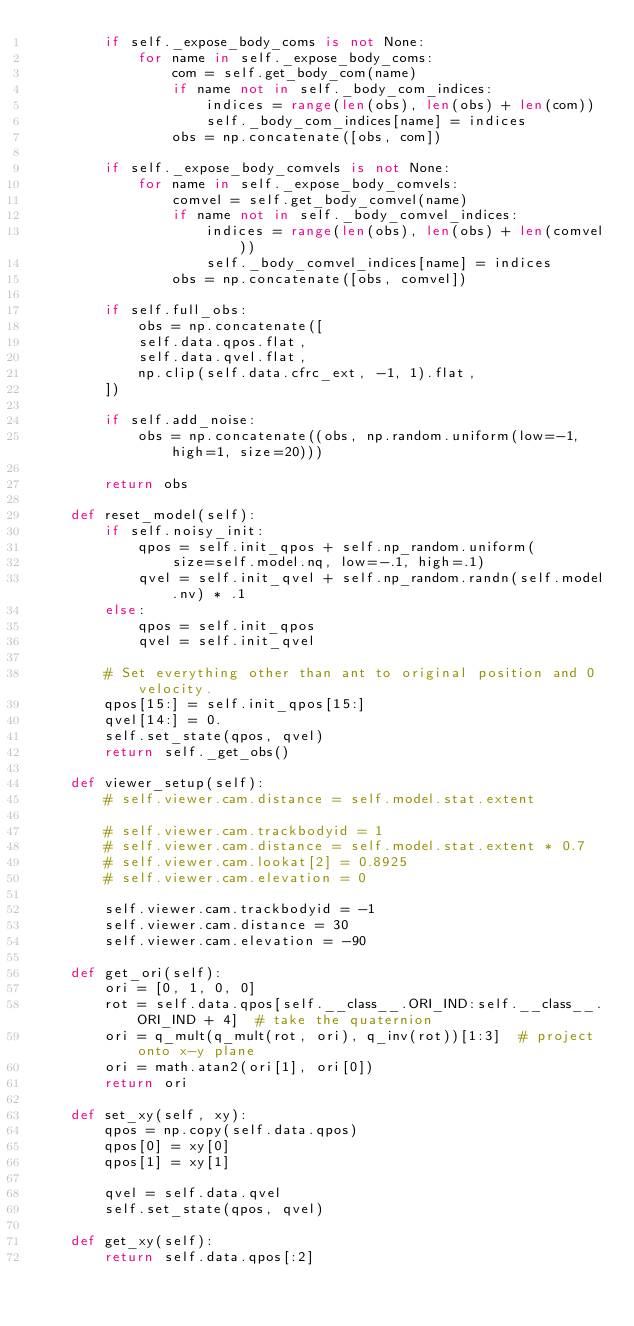Convert code to text. <code><loc_0><loc_0><loc_500><loc_500><_Python_>        if self._expose_body_coms is not None:
            for name in self._expose_body_coms:
                com = self.get_body_com(name)
                if name not in self._body_com_indices:
                    indices = range(len(obs), len(obs) + len(com))
                    self._body_com_indices[name] = indices
                obs = np.concatenate([obs, com])

        if self._expose_body_comvels is not None:
            for name in self._expose_body_comvels:
                comvel = self.get_body_comvel(name)
                if name not in self._body_comvel_indices:
                    indices = range(len(obs), len(obs) + len(comvel))
                    self._body_comvel_indices[name] = indices
                obs = np.concatenate([obs, comvel])

        if self.full_obs:
            obs = np.concatenate([
            self.data.qpos.flat,
            self.data.qvel.flat,
            np.clip(self.data.cfrc_ext, -1, 1).flat,
        ])

        if self.add_noise:
            obs = np.concatenate((obs, np.random.uniform(low=-1, high=1, size=20)))

        return obs

    def reset_model(self):
        if self.noisy_init:
            qpos = self.init_qpos + self.np_random.uniform(
                size=self.model.nq, low=-.1, high=.1)
            qvel = self.init_qvel + self.np_random.randn(self.model.nv) * .1
        else:
            qpos = self.init_qpos
            qvel = self.init_qvel

        # Set everything other than ant to original position and 0 velocity.
        qpos[15:] = self.init_qpos[15:]
        qvel[14:] = 0.
        self.set_state(qpos, qvel)
        return self._get_obs()

    def viewer_setup(self):
        # self.viewer.cam.distance = self.model.stat.extent

        # self.viewer.cam.trackbodyid = 1
        # self.viewer.cam.distance = self.model.stat.extent * 0.7
        # self.viewer.cam.lookat[2] = 0.8925
        # self.viewer.cam.elevation = 0

        self.viewer.cam.trackbodyid = -1
        self.viewer.cam.distance = 30
        self.viewer.cam.elevation = -90

    def get_ori(self):
        ori = [0, 1, 0, 0]
        rot = self.data.qpos[self.__class__.ORI_IND:self.__class__.ORI_IND + 4]  # take the quaternion
        ori = q_mult(q_mult(rot, ori), q_inv(rot))[1:3]  # project onto x-y plane
        ori = math.atan2(ori[1], ori[0])
        return ori

    def set_xy(self, xy):
        qpos = np.copy(self.data.qpos)
        qpos[0] = xy[0]
        qpos[1] = xy[1]

        qvel = self.data.qvel
        self.set_state(qpos, qvel)

    def get_xy(self):
        return self.data.qpos[:2]
</code> 